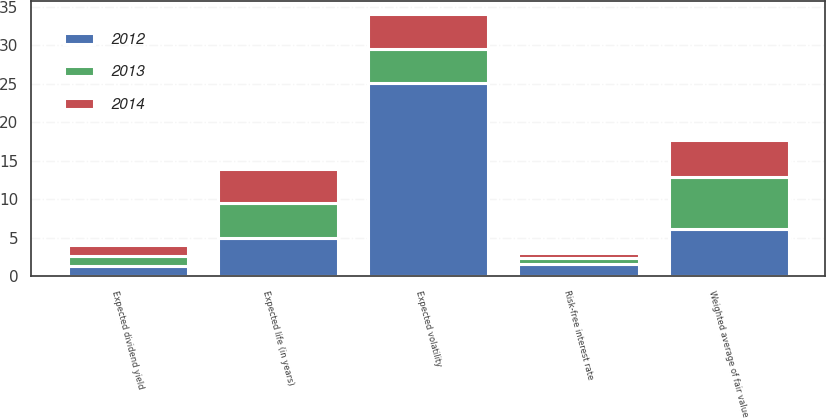Convert chart. <chart><loc_0><loc_0><loc_500><loc_500><stacked_bar_chart><ecel><fcel>Weighted average of fair value<fcel>Expected dividend yield<fcel>Expected volatility<fcel>Risk-free interest rate<fcel>Expected life (in years)<nl><fcel>2012<fcel>6.1<fcel>1.3<fcel>25.1<fcel>1.55<fcel>5<nl><fcel>2013<fcel>6.79<fcel>1.3<fcel>4.5<fcel>0.78<fcel>4.5<nl><fcel>2014<fcel>4.88<fcel>1.5<fcel>4.5<fcel>0.67<fcel>4.5<nl></chart> 